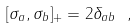<formula> <loc_0><loc_0><loc_500><loc_500>[ \sigma _ { a } , \sigma _ { b } ] _ { + } = 2 \delta _ { a b } \ ,</formula> 